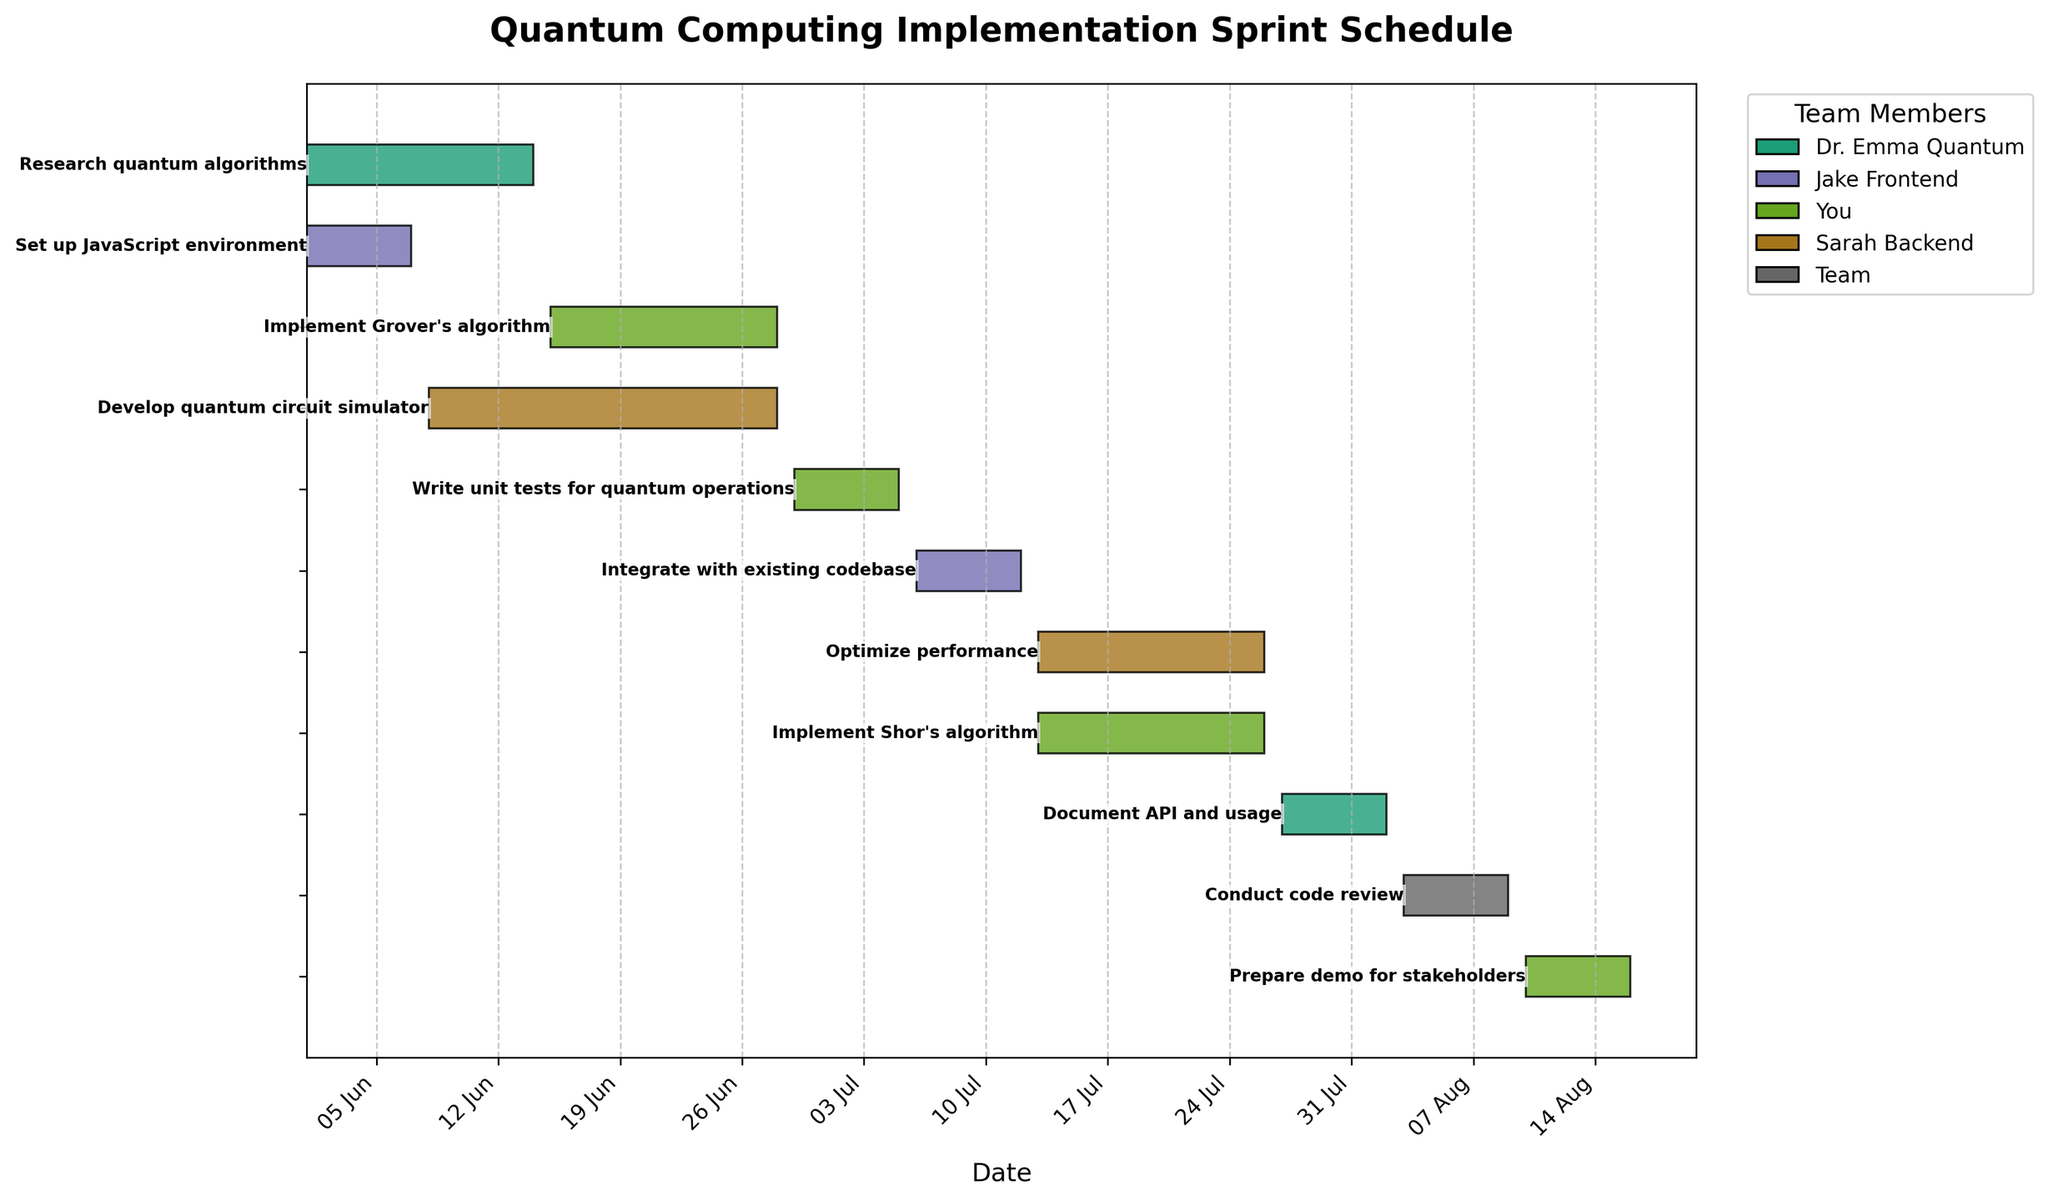What is the title of the plot? The title is typically centered at the top of the plot, often displayed in a larger font size. Here, the title is "Quantum Computing Implementation Sprint Schedule".
Answer: Quantum Computing Implementation Sprint Schedule Which team member has tasks starting on June 1, 2023? By looking at the tasks and their start dates, we can see that "Research quantum algorithms" and "Set up JavaScript environment" both start on June 1, 2023, handled by Dr. Emma Quantum and Jake Frontend, respectively.
Answer: Dr. Emma Quantum and Jake Frontend Who is responsible for implementing Grover's algorithm and what are the start and end dates? In the Gantt chart, check the task labeled "Implement Grover's algorithm," which lists the dates and responsible team member. This task is handled by you, starting on June 15, 2023, and ending on June 28, 2023.
Answer: You, June 15, 2023, to June 28, 2023 What is the longest single task duration and which task is it? The task durations are represented by the length of the horizontal bars. The task "Develop quantum circuit simulator" spans from June 8 to June 28, which is 20 days.
Answer: Develop quantum circuit simulator, 20 days How many tasks does Sarah Backend have, and what are they? By noting the tasks associated with Sarah Backend by their colors, Sarah has two tasks: "Develop quantum circuit simulator" and "Optimize performance".
Answer: Two tasks: Develop quantum circuit simulator and Optimize performance What are the start and end dates for "Document API and usage"? The task "Document API and usage" has its dates shown directly on its corresponding bar in the chart. It starts on July 27, 2023, and ends on August 2, 2023.
Answer: July 27, 2023, to August 2, 2023 Which two tasks run concurrently with "Optimize performance"? Locate the "Optimize performance" task on the chart and check other tasks that overlap its duration from July 13, 2023, to July 26, 2023. The overlapping tasks are "Implement Shor's algorithm," managed by you.
Answer: Implement Shor's algorithm Who is responsible for the task with the shortest duration, and what is the task? By evaluating the lengths of all horizontal bars, the shortest task is "Write unit tests for quantum operations," lasting from June 29, 2023, to July 5, 2023, and it's managed by you.
Answer: You, Write unit tests for quantum operations Calculate the total number of days you are scheduled to work on tasks. You are responsible for "Implement Grover's algorithm" (14 days), "Write unit tests for quantum operations" (7 days), "Implement Shor's algorithm" (14 days), and "Prepare demo for stakeholders" (7 days). Total = 14 + 7 + 14 + 7 = 42 days.
Answer: 42 days What role does the entire team play in the schedule, and when does it occur? Identify the task labeled "Conduct code review"; it includes the entire team and occurs from August 3, 2023, to August 9, 2023.
Answer: Conduct code review, August 3, 2023, to August 9, 2023 